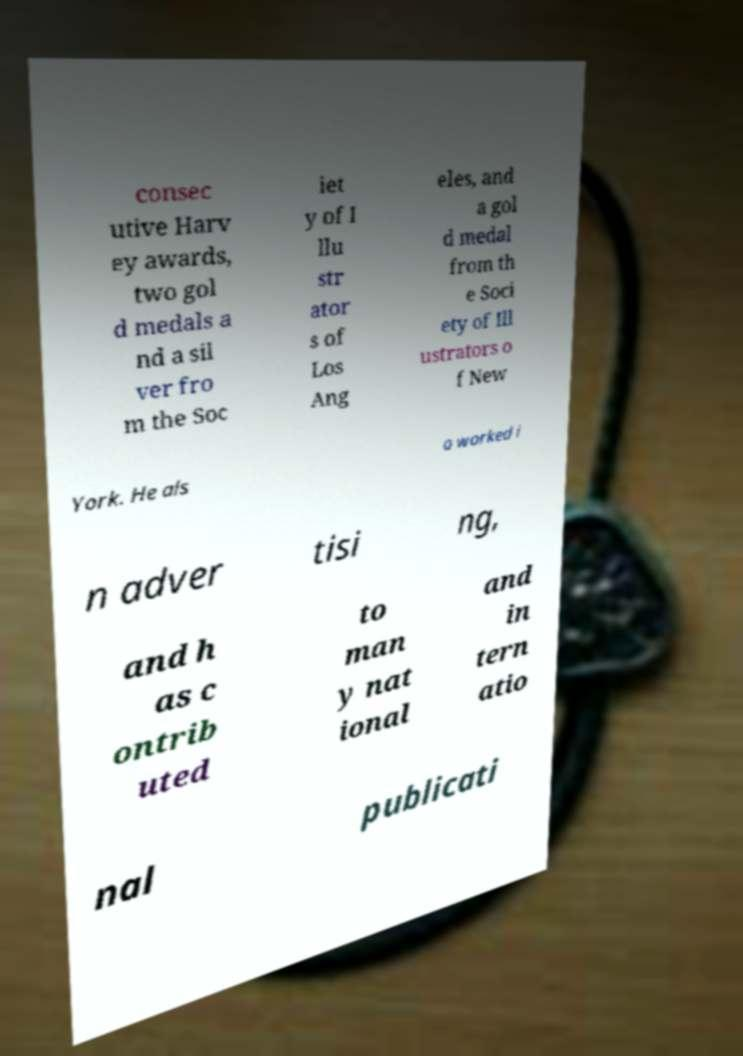Can you read and provide the text displayed in the image?This photo seems to have some interesting text. Can you extract and type it out for me? consec utive Harv ey awards, two gol d medals a nd a sil ver fro m the Soc iet y of I llu str ator s of Los Ang eles, and a gol d medal from th e Soci ety of Ill ustrators o f New York. He als o worked i n adver tisi ng, and h as c ontrib uted to man y nat ional and in tern atio nal publicati 